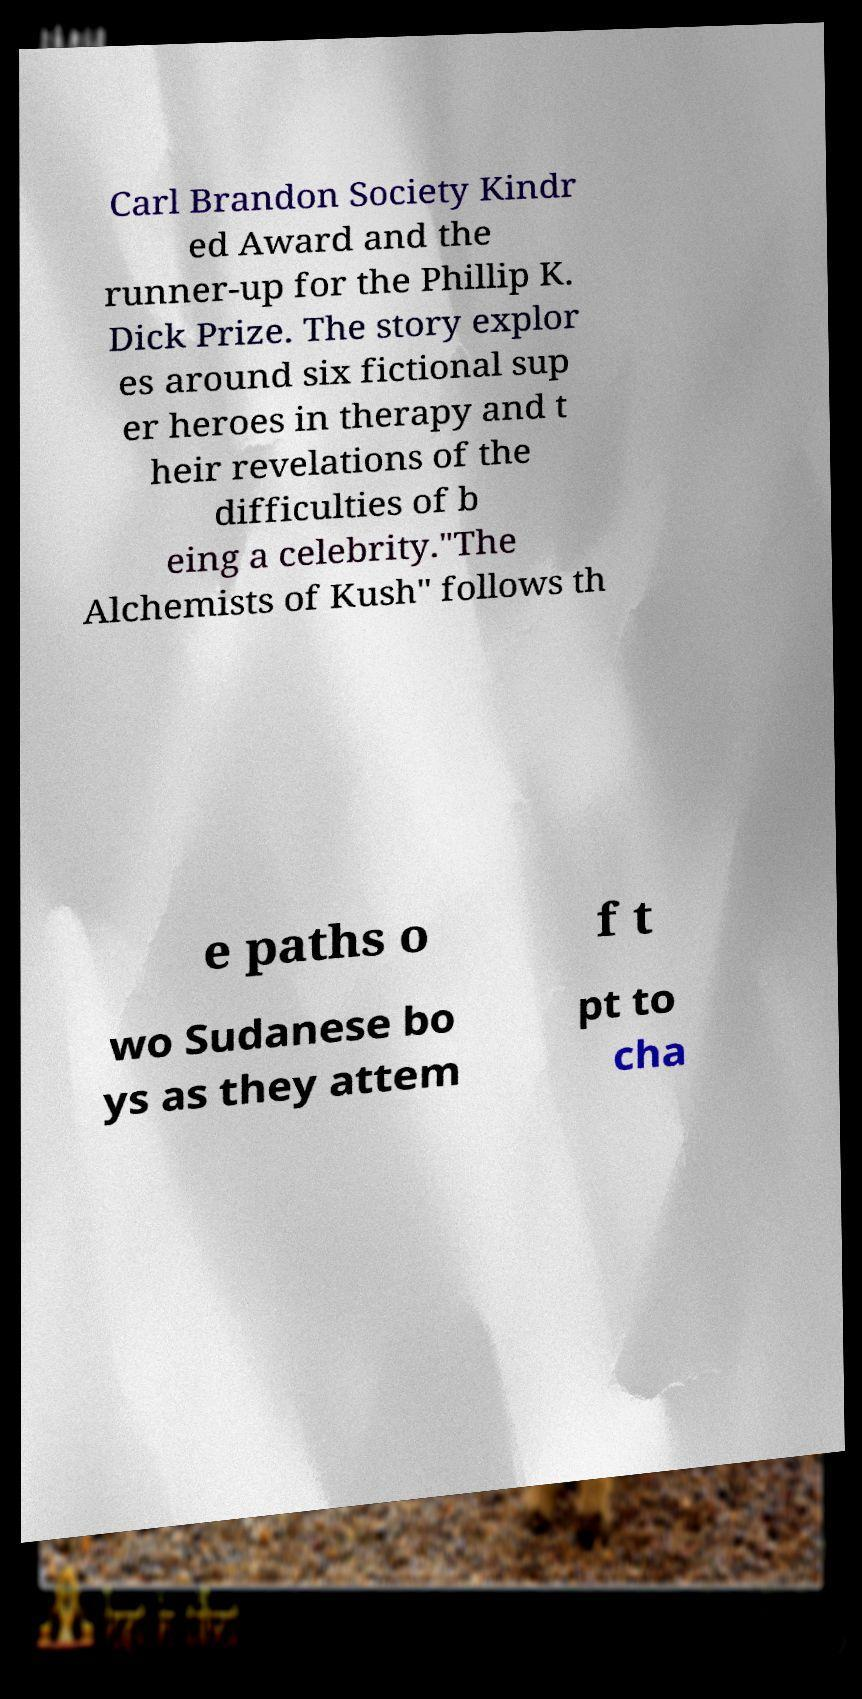I need the written content from this picture converted into text. Can you do that? Carl Brandon Society Kindr ed Award and the runner-up for the Phillip K. Dick Prize. The story explor es around six fictional sup er heroes in therapy and t heir revelations of the difficulties of b eing a celebrity."The Alchemists of Kush" follows th e paths o f t wo Sudanese bo ys as they attem pt to cha 